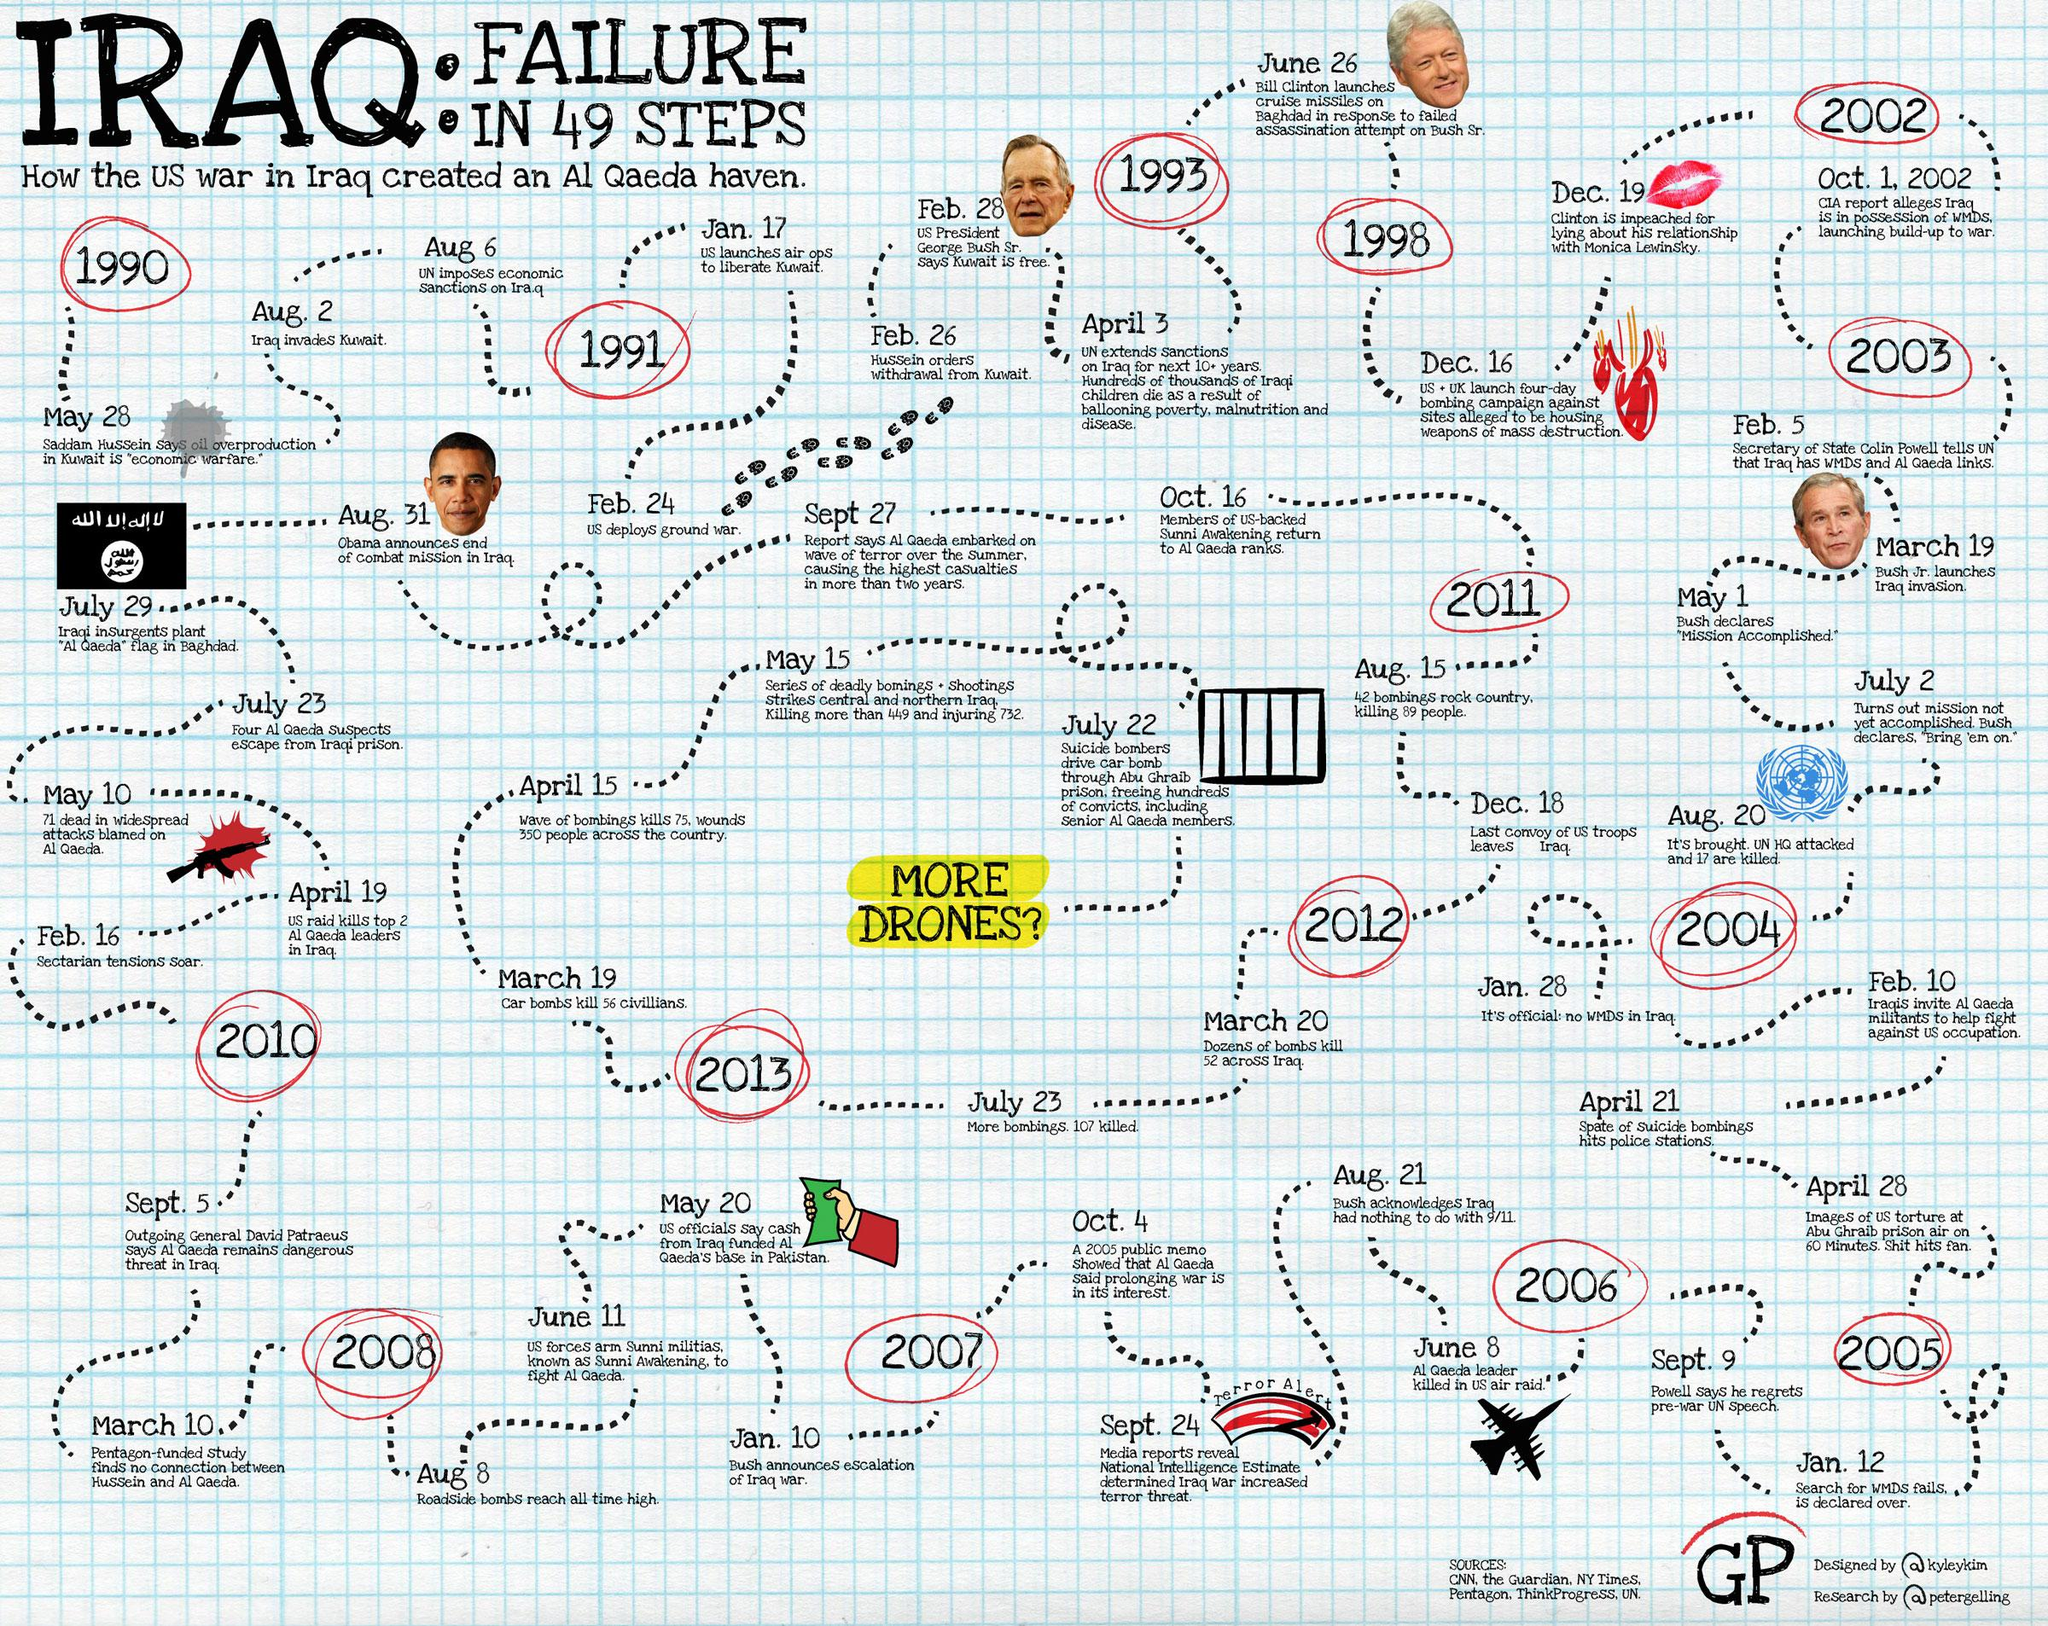Highlight a few significant elements in this photo. Six sources are listed. The infographic displays four US presidents. The infographic displays only one plane. The social media handle of the researcher of the infographic is @petergelling. The social media handle of the designer of the infographic is @kyleykim. 